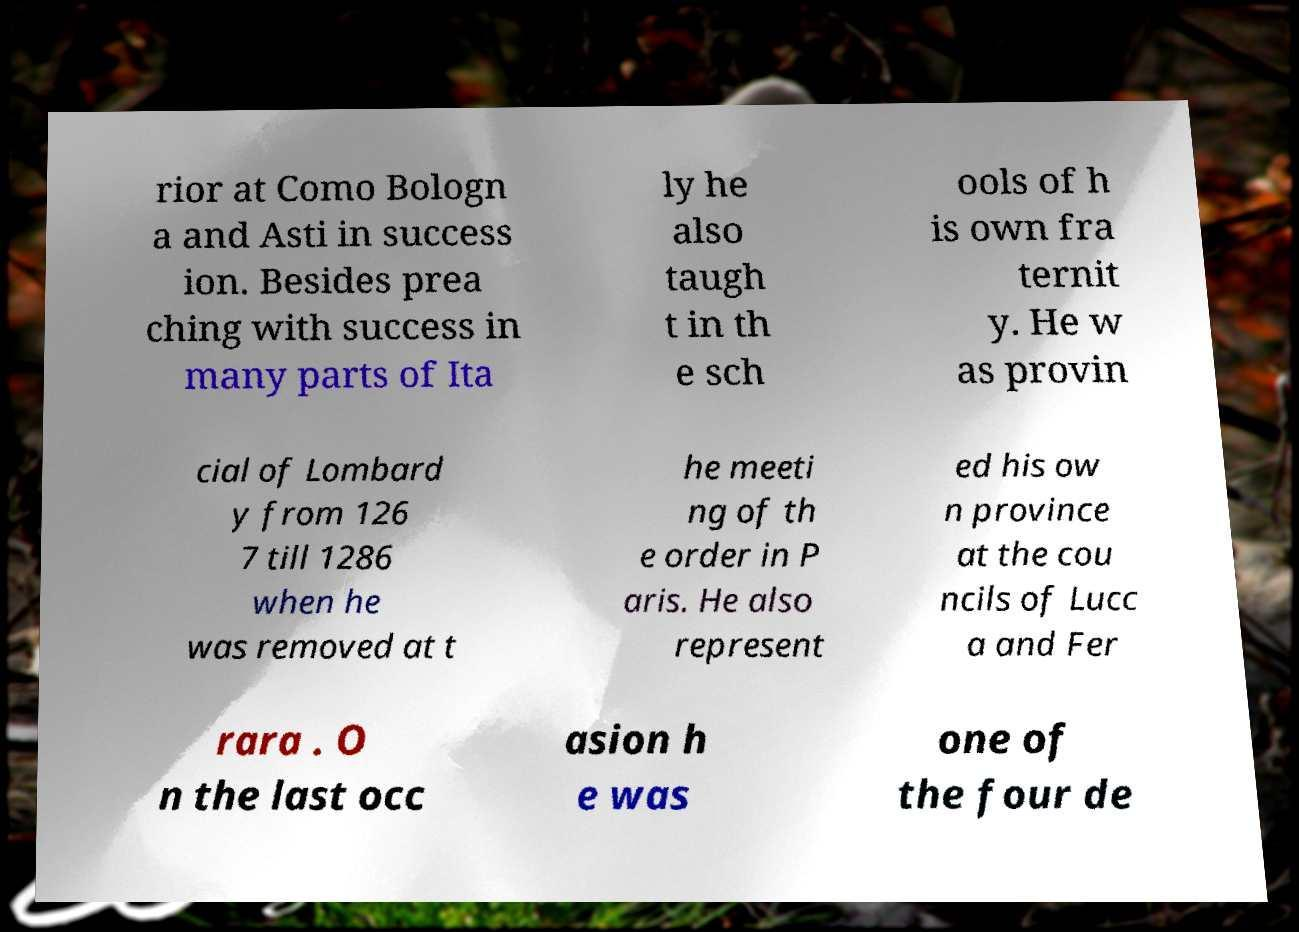Could you extract and type out the text from this image? rior at Como Bologn a and Asti in success ion. Besides prea ching with success in many parts of Ita ly he also taugh t in th e sch ools of h is own fra ternit y. He w as provin cial of Lombard y from 126 7 till 1286 when he was removed at t he meeti ng of th e order in P aris. He also represent ed his ow n province at the cou ncils of Lucc a and Fer rara . O n the last occ asion h e was one of the four de 